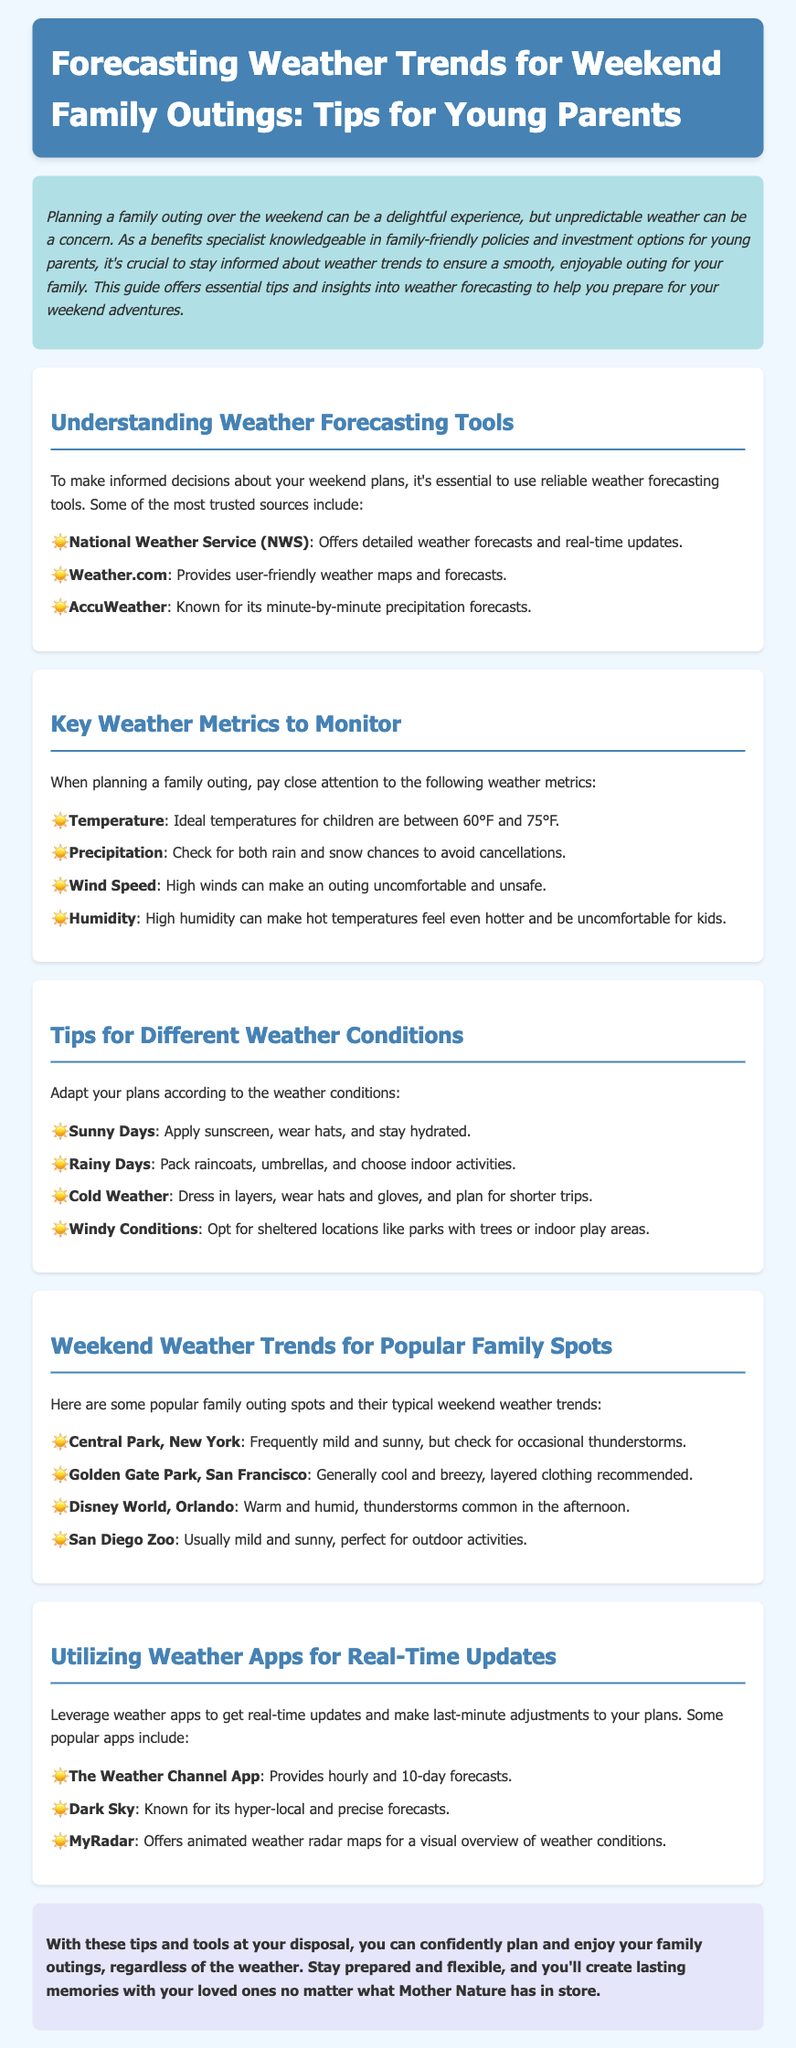What is the title of the document? The title is presented in the header section of the document and provides the main topic being discussed.
Answer: Forecasting Weather Trends for Weekend Family Outings: Tips for Young Parents What is the ideal temperature range for children? This information is found under the "Key Weather Metrics to Monitor" section, providing guidance on suitable temperatures for children's outings.
Answer: 60°F to 75°F Which weather forecasting tool is known for its minute-by-minute precipitation forecasts? This refers to the listed weather tools and their attributes in the "Understanding Weather Forecasting Tools" section.
Answer: AccuWeather What should you pack for rainy days? The document offers specific advice for different weather conditions, including what to bring for rainy weather.
Answer: Raincoats, umbrellas What is the typical weather at Disney World, Orlando? The answer can be found in the section about weekend weather trends, summarizing common conditions at that location.
Answer: Warm and humid What should you do on sunny days according to the document? This question pertains to the practical tips given for sunny weather found in the "Tips for Different Weather Conditions" section.
Answer: Apply sunscreen, wear hats, and stay hydrated What is a recommended app for real-time weather updates? The document lists specific applications that provide weather updates, highlighting their functionalities in the "Utilizing Weather Apps for Real-Time Updates" section.
Answer: The Weather Channel App What family outing spot is described as generally cool and breezy? This refers to the specific locations and their weather characteristics mentioned in the "Weekend Weather Trends for Popular Family Spots" section.
Answer: Golden Gate Park, San Francisco 